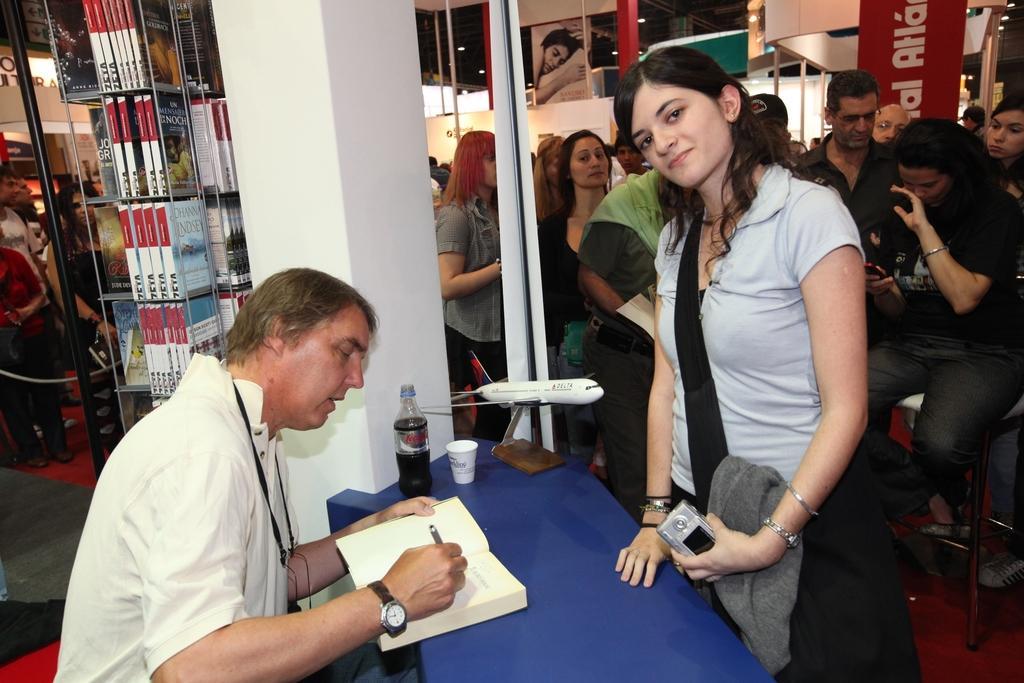Can you describe this image briefly? In the center of the image there is a table and we can see a book, cup and a bottle placed on the table. On the left there is a man sitting and writing. There is a shelf and we can see books placed in the shelf. In the background there are people standing and we can see a wall. 